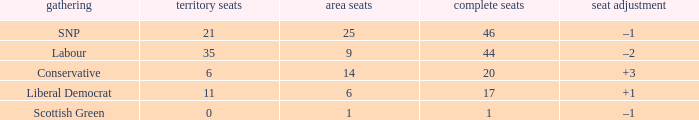What is the full number of Total Seats with a constituency seat number bigger than 0 with the Liberal Democrat party, and the Regional seat number is smaller than 6? None. I'm looking to parse the entire table for insights. Could you assist me with that? {'header': ['gathering', 'territory seats', 'area seats', 'complete seats', 'seat adjustment'], 'rows': [['SNP', '21', '25', '46', '–1'], ['Labour', '35', '9', '44', '–2'], ['Conservative', '6', '14', '20', '+3'], ['Liberal Democrat', '11', '6', '17', '+1'], ['Scottish Green', '0', '1', '1', '–1']]} 